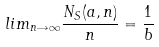Convert formula to latex. <formula><loc_0><loc_0><loc_500><loc_500>l i m _ { n \rightarrow \infty } \frac { N _ { S } ( a , n ) } { n } = \frac { 1 } { b }</formula> 